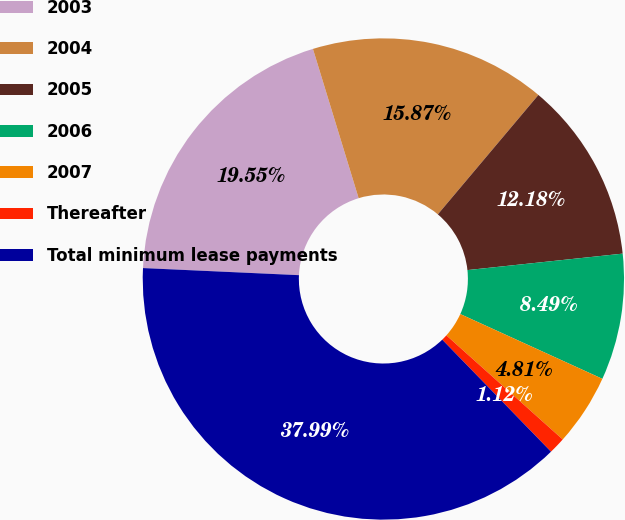Convert chart to OTSL. <chart><loc_0><loc_0><loc_500><loc_500><pie_chart><fcel>2003<fcel>2004<fcel>2005<fcel>2006<fcel>2007<fcel>Thereafter<fcel>Total minimum lease payments<nl><fcel>19.55%<fcel>15.87%<fcel>12.18%<fcel>8.49%<fcel>4.81%<fcel>1.12%<fcel>37.99%<nl></chart> 